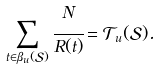Convert formula to latex. <formula><loc_0><loc_0><loc_500><loc_500>\sum _ { t \in \beta _ { u } ( \mathcal { S } ) } \cfrac { N } { R ( t ) } = \mathcal { T } _ { u } ( \mathcal { S } ) .</formula> 